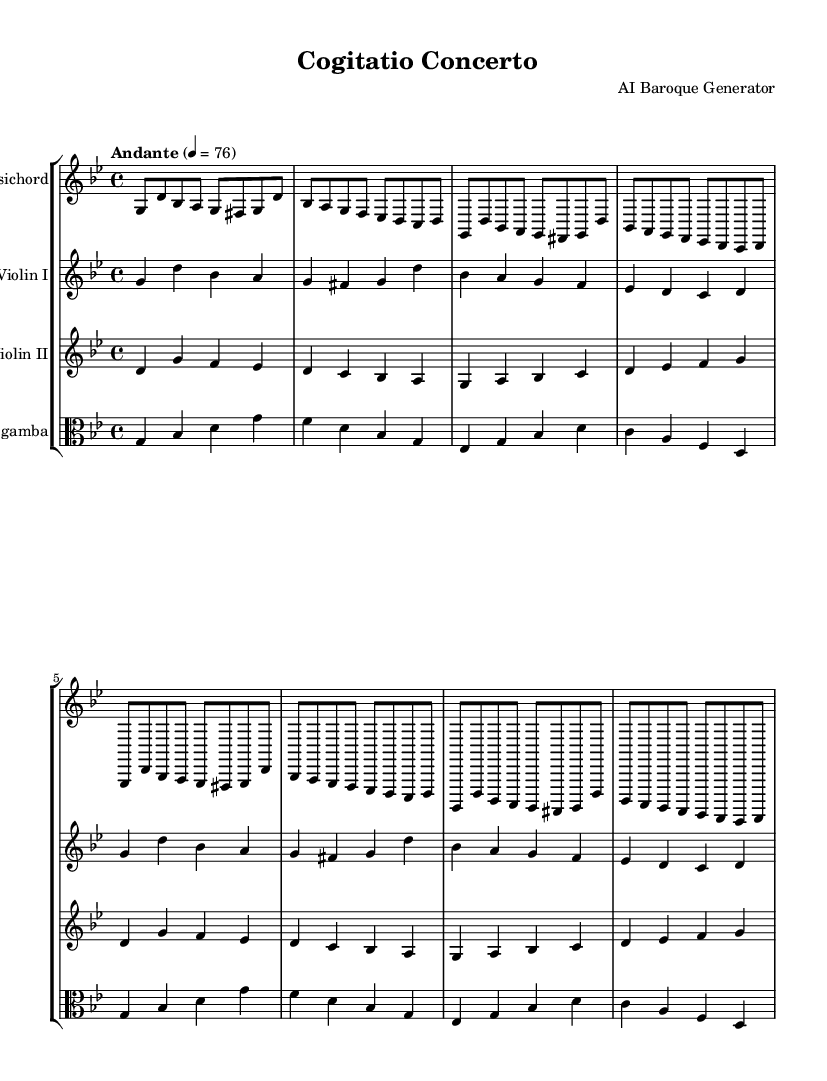What is the key signature of this music? The key signature is indicated at the beginning of the staff with a flat (♭) symbol, which shows G minor has two flats: B♭ and E♭.
Answer: G minor What is the time signature of this music? The time signature is displayed at the beginning of the score as a fraction, showing four beats per measure; the upper number is 4, and the lower number is 4.
Answer: 4/4 What is the tempo marking of this piece? The tempo marking “Andante” appears above the staff, with a metronome marking of quarter note equals 76, indicating a moderately slow pace.
Answer: Andante How many measures are in the first section for Harpsichord? The harpsichord part consists of four repetitions of the same eight-note phrase, which is divided into eight measures total.
Answer: 8 Which instrument plays the melody in the upper register? In the score, the first violin part is written in a higher pitch range, making it the primary carrier of the melody throughout the piece.
Answer: Violin I What is the range of the Viola part in the score? The viola part is noted in the clef that indicates where the notes are relative to the staff and typically ranges from the lower G to the higher D in standard notation.
Answer: G to D How does the Violin II part interact with the Violin I part? Violin II provides counter-melodies and harmonizes with the Violin I part, enriching the texture of the piece through complementary musical lines.
Answer: Counter-melodies 